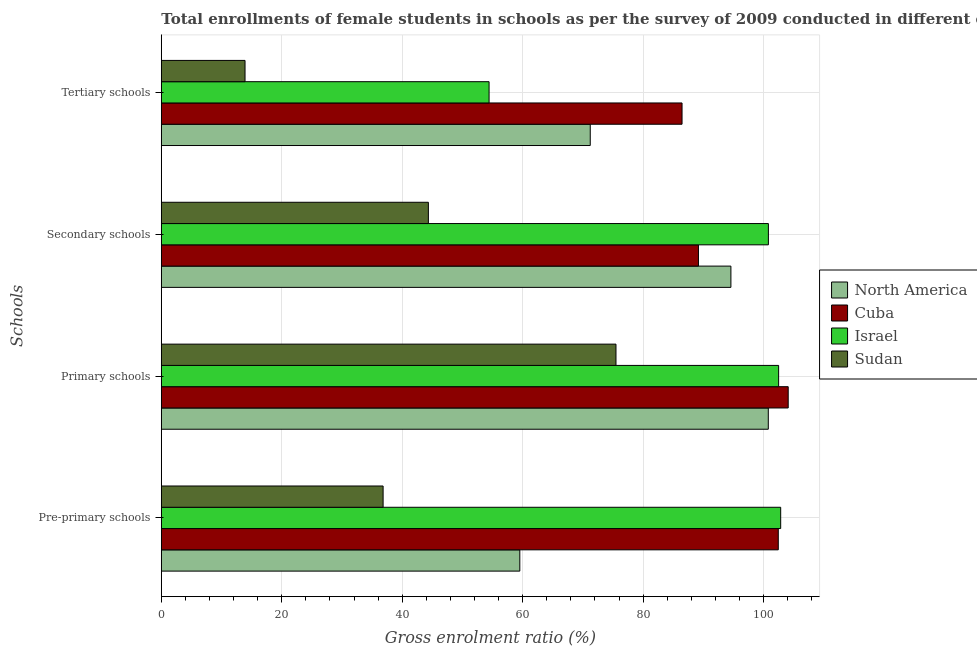How many different coloured bars are there?
Keep it short and to the point. 4. How many groups of bars are there?
Offer a terse response. 4. Are the number of bars per tick equal to the number of legend labels?
Provide a succinct answer. Yes. Are the number of bars on each tick of the Y-axis equal?
Your answer should be compact. Yes. How many bars are there on the 3rd tick from the bottom?
Give a very brief answer. 4. What is the label of the 2nd group of bars from the top?
Offer a very short reply. Secondary schools. What is the gross enrolment ratio(female) in primary schools in Sudan?
Provide a succinct answer. 75.5. Across all countries, what is the maximum gross enrolment ratio(female) in pre-primary schools?
Offer a terse response. 102.85. Across all countries, what is the minimum gross enrolment ratio(female) in pre-primary schools?
Give a very brief answer. 36.83. In which country was the gross enrolment ratio(female) in secondary schools minimum?
Keep it short and to the point. Sudan. What is the total gross enrolment ratio(female) in secondary schools in the graph?
Your response must be concise. 328.92. What is the difference between the gross enrolment ratio(female) in tertiary schools in North America and that in Israel?
Provide a short and direct response. 16.8. What is the difference between the gross enrolment ratio(female) in secondary schools in North America and the gross enrolment ratio(female) in tertiary schools in Israel?
Give a very brief answer. 40.15. What is the average gross enrolment ratio(female) in primary schools per country?
Your answer should be compact. 95.72. What is the difference between the gross enrolment ratio(female) in primary schools and gross enrolment ratio(female) in pre-primary schools in Sudan?
Provide a succinct answer. 38.67. In how many countries, is the gross enrolment ratio(female) in tertiary schools greater than 68 %?
Give a very brief answer. 2. What is the ratio of the gross enrolment ratio(female) in secondary schools in Israel to that in Cuba?
Your response must be concise. 1.13. Is the gross enrolment ratio(female) in pre-primary schools in Israel less than that in Cuba?
Offer a terse response. No. What is the difference between the highest and the second highest gross enrolment ratio(female) in tertiary schools?
Provide a succinct answer. 15.24. What is the difference between the highest and the lowest gross enrolment ratio(female) in primary schools?
Provide a short and direct response. 28.6. Is the sum of the gross enrolment ratio(female) in secondary schools in Israel and Cuba greater than the maximum gross enrolment ratio(female) in tertiary schools across all countries?
Ensure brevity in your answer.  Yes. How many bars are there?
Offer a terse response. 16. How many countries are there in the graph?
Your answer should be very brief. 4. What is the difference between two consecutive major ticks on the X-axis?
Your answer should be very brief. 20. Are the values on the major ticks of X-axis written in scientific E-notation?
Offer a very short reply. No. Does the graph contain grids?
Ensure brevity in your answer.  Yes. How many legend labels are there?
Your response must be concise. 4. How are the legend labels stacked?
Your response must be concise. Vertical. What is the title of the graph?
Provide a succinct answer. Total enrollments of female students in schools as per the survey of 2009 conducted in different countries. Does "Guyana" appear as one of the legend labels in the graph?
Keep it short and to the point. No. What is the label or title of the Y-axis?
Keep it short and to the point. Schools. What is the Gross enrolment ratio (%) of North America in Pre-primary schools?
Provide a succinct answer. 59.53. What is the Gross enrolment ratio (%) in Cuba in Pre-primary schools?
Your answer should be very brief. 102.45. What is the Gross enrolment ratio (%) in Israel in Pre-primary schools?
Your response must be concise. 102.85. What is the Gross enrolment ratio (%) in Sudan in Pre-primary schools?
Your answer should be compact. 36.83. What is the Gross enrolment ratio (%) in North America in Primary schools?
Offer a very short reply. 100.79. What is the Gross enrolment ratio (%) in Cuba in Primary schools?
Your answer should be compact. 104.1. What is the Gross enrolment ratio (%) in Israel in Primary schools?
Your response must be concise. 102.5. What is the Gross enrolment ratio (%) in Sudan in Primary schools?
Make the answer very short. 75.5. What is the Gross enrolment ratio (%) in North America in Secondary schools?
Make the answer very short. 94.58. What is the Gross enrolment ratio (%) in Cuba in Secondary schools?
Your response must be concise. 89.19. What is the Gross enrolment ratio (%) in Israel in Secondary schools?
Give a very brief answer. 100.81. What is the Gross enrolment ratio (%) of Sudan in Secondary schools?
Ensure brevity in your answer.  44.35. What is the Gross enrolment ratio (%) of North America in Tertiary schools?
Give a very brief answer. 71.23. What is the Gross enrolment ratio (%) in Cuba in Tertiary schools?
Offer a terse response. 86.47. What is the Gross enrolment ratio (%) of Israel in Tertiary schools?
Offer a very short reply. 54.43. What is the Gross enrolment ratio (%) in Sudan in Tertiary schools?
Your answer should be compact. 13.9. Across all Schools, what is the maximum Gross enrolment ratio (%) of North America?
Give a very brief answer. 100.79. Across all Schools, what is the maximum Gross enrolment ratio (%) of Cuba?
Offer a terse response. 104.1. Across all Schools, what is the maximum Gross enrolment ratio (%) in Israel?
Give a very brief answer. 102.85. Across all Schools, what is the maximum Gross enrolment ratio (%) of Sudan?
Make the answer very short. 75.5. Across all Schools, what is the minimum Gross enrolment ratio (%) of North America?
Provide a short and direct response. 59.53. Across all Schools, what is the minimum Gross enrolment ratio (%) of Cuba?
Offer a terse response. 86.47. Across all Schools, what is the minimum Gross enrolment ratio (%) in Israel?
Keep it short and to the point. 54.43. Across all Schools, what is the minimum Gross enrolment ratio (%) in Sudan?
Your answer should be compact. 13.9. What is the total Gross enrolment ratio (%) in North America in the graph?
Your response must be concise. 326.12. What is the total Gross enrolment ratio (%) of Cuba in the graph?
Provide a succinct answer. 382.2. What is the total Gross enrolment ratio (%) of Israel in the graph?
Your response must be concise. 360.58. What is the total Gross enrolment ratio (%) of Sudan in the graph?
Your answer should be compact. 170.57. What is the difference between the Gross enrolment ratio (%) in North America in Pre-primary schools and that in Primary schools?
Offer a very short reply. -41.26. What is the difference between the Gross enrolment ratio (%) in Cuba in Pre-primary schools and that in Primary schools?
Provide a succinct answer. -1.65. What is the difference between the Gross enrolment ratio (%) of Israel in Pre-primary schools and that in Primary schools?
Provide a succinct answer. 0.34. What is the difference between the Gross enrolment ratio (%) of Sudan in Pre-primary schools and that in Primary schools?
Ensure brevity in your answer.  -38.67. What is the difference between the Gross enrolment ratio (%) of North America in Pre-primary schools and that in Secondary schools?
Keep it short and to the point. -35.05. What is the difference between the Gross enrolment ratio (%) of Cuba in Pre-primary schools and that in Secondary schools?
Provide a short and direct response. 13.26. What is the difference between the Gross enrolment ratio (%) of Israel in Pre-primary schools and that in Secondary schools?
Provide a succinct answer. 2.04. What is the difference between the Gross enrolment ratio (%) of Sudan in Pre-primary schools and that in Secondary schools?
Ensure brevity in your answer.  -7.52. What is the difference between the Gross enrolment ratio (%) in North America in Pre-primary schools and that in Tertiary schools?
Ensure brevity in your answer.  -11.7. What is the difference between the Gross enrolment ratio (%) in Cuba in Pre-primary schools and that in Tertiary schools?
Provide a succinct answer. 15.98. What is the difference between the Gross enrolment ratio (%) in Israel in Pre-primary schools and that in Tertiary schools?
Your answer should be compact. 48.42. What is the difference between the Gross enrolment ratio (%) of Sudan in Pre-primary schools and that in Tertiary schools?
Make the answer very short. 22.93. What is the difference between the Gross enrolment ratio (%) in North America in Primary schools and that in Secondary schools?
Provide a short and direct response. 6.21. What is the difference between the Gross enrolment ratio (%) in Cuba in Primary schools and that in Secondary schools?
Provide a succinct answer. 14.9. What is the difference between the Gross enrolment ratio (%) in Israel in Primary schools and that in Secondary schools?
Provide a succinct answer. 1.7. What is the difference between the Gross enrolment ratio (%) of Sudan in Primary schools and that in Secondary schools?
Provide a short and direct response. 31.15. What is the difference between the Gross enrolment ratio (%) in North America in Primary schools and that in Tertiary schools?
Ensure brevity in your answer.  29.56. What is the difference between the Gross enrolment ratio (%) of Cuba in Primary schools and that in Tertiary schools?
Ensure brevity in your answer.  17.63. What is the difference between the Gross enrolment ratio (%) of Israel in Primary schools and that in Tertiary schools?
Ensure brevity in your answer.  48.08. What is the difference between the Gross enrolment ratio (%) of Sudan in Primary schools and that in Tertiary schools?
Ensure brevity in your answer.  61.6. What is the difference between the Gross enrolment ratio (%) in North America in Secondary schools and that in Tertiary schools?
Provide a short and direct response. 23.35. What is the difference between the Gross enrolment ratio (%) of Cuba in Secondary schools and that in Tertiary schools?
Offer a terse response. 2.73. What is the difference between the Gross enrolment ratio (%) of Israel in Secondary schools and that in Tertiary schools?
Your answer should be very brief. 46.38. What is the difference between the Gross enrolment ratio (%) in Sudan in Secondary schools and that in Tertiary schools?
Keep it short and to the point. 30.44. What is the difference between the Gross enrolment ratio (%) in North America in Pre-primary schools and the Gross enrolment ratio (%) in Cuba in Primary schools?
Your response must be concise. -44.57. What is the difference between the Gross enrolment ratio (%) of North America in Pre-primary schools and the Gross enrolment ratio (%) of Israel in Primary schools?
Give a very brief answer. -42.98. What is the difference between the Gross enrolment ratio (%) in North America in Pre-primary schools and the Gross enrolment ratio (%) in Sudan in Primary schools?
Offer a very short reply. -15.97. What is the difference between the Gross enrolment ratio (%) of Cuba in Pre-primary schools and the Gross enrolment ratio (%) of Israel in Primary schools?
Make the answer very short. -0.06. What is the difference between the Gross enrolment ratio (%) of Cuba in Pre-primary schools and the Gross enrolment ratio (%) of Sudan in Primary schools?
Offer a terse response. 26.95. What is the difference between the Gross enrolment ratio (%) in Israel in Pre-primary schools and the Gross enrolment ratio (%) in Sudan in Primary schools?
Give a very brief answer. 27.35. What is the difference between the Gross enrolment ratio (%) in North America in Pre-primary schools and the Gross enrolment ratio (%) in Cuba in Secondary schools?
Your answer should be compact. -29.66. What is the difference between the Gross enrolment ratio (%) of North America in Pre-primary schools and the Gross enrolment ratio (%) of Israel in Secondary schools?
Provide a succinct answer. -41.28. What is the difference between the Gross enrolment ratio (%) in North America in Pre-primary schools and the Gross enrolment ratio (%) in Sudan in Secondary schools?
Provide a short and direct response. 15.18. What is the difference between the Gross enrolment ratio (%) in Cuba in Pre-primary schools and the Gross enrolment ratio (%) in Israel in Secondary schools?
Offer a terse response. 1.64. What is the difference between the Gross enrolment ratio (%) of Cuba in Pre-primary schools and the Gross enrolment ratio (%) of Sudan in Secondary schools?
Offer a terse response. 58.1. What is the difference between the Gross enrolment ratio (%) of Israel in Pre-primary schools and the Gross enrolment ratio (%) of Sudan in Secondary schools?
Offer a very short reply. 58.5. What is the difference between the Gross enrolment ratio (%) of North America in Pre-primary schools and the Gross enrolment ratio (%) of Cuba in Tertiary schools?
Your answer should be very brief. -26.94. What is the difference between the Gross enrolment ratio (%) of North America in Pre-primary schools and the Gross enrolment ratio (%) of Israel in Tertiary schools?
Keep it short and to the point. 5.1. What is the difference between the Gross enrolment ratio (%) of North America in Pre-primary schools and the Gross enrolment ratio (%) of Sudan in Tertiary schools?
Your response must be concise. 45.63. What is the difference between the Gross enrolment ratio (%) of Cuba in Pre-primary schools and the Gross enrolment ratio (%) of Israel in Tertiary schools?
Keep it short and to the point. 48.02. What is the difference between the Gross enrolment ratio (%) in Cuba in Pre-primary schools and the Gross enrolment ratio (%) in Sudan in Tertiary schools?
Offer a very short reply. 88.55. What is the difference between the Gross enrolment ratio (%) of Israel in Pre-primary schools and the Gross enrolment ratio (%) of Sudan in Tertiary schools?
Make the answer very short. 88.94. What is the difference between the Gross enrolment ratio (%) in North America in Primary schools and the Gross enrolment ratio (%) in Cuba in Secondary schools?
Provide a short and direct response. 11.6. What is the difference between the Gross enrolment ratio (%) in North America in Primary schools and the Gross enrolment ratio (%) in Israel in Secondary schools?
Give a very brief answer. -0.02. What is the difference between the Gross enrolment ratio (%) of North America in Primary schools and the Gross enrolment ratio (%) of Sudan in Secondary schools?
Offer a terse response. 56.44. What is the difference between the Gross enrolment ratio (%) of Cuba in Primary schools and the Gross enrolment ratio (%) of Israel in Secondary schools?
Ensure brevity in your answer.  3.29. What is the difference between the Gross enrolment ratio (%) of Cuba in Primary schools and the Gross enrolment ratio (%) of Sudan in Secondary schools?
Your answer should be compact. 59.75. What is the difference between the Gross enrolment ratio (%) in Israel in Primary schools and the Gross enrolment ratio (%) in Sudan in Secondary schools?
Your answer should be very brief. 58.16. What is the difference between the Gross enrolment ratio (%) in North America in Primary schools and the Gross enrolment ratio (%) in Cuba in Tertiary schools?
Ensure brevity in your answer.  14.32. What is the difference between the Gross enrolment ratio (%) in North America in Primary schools and the Gross enrolment ratio (%) in Israel in Tertiary schools?
Keep it short and to the point. 46.36. What is the difference between the Gross enrolment ratio (%) of North America in Primary schools and the Gross enrolment ratio (%) of Sudan in Tertiary schools?
Ensure brevity in your answer.  86.89. What is the difference between the Gross enrolment ratio (%) of Cuba in Primary schools and the Gross enrolment ratio (%) of Israel in Tertiary schools?
Ensure brevity in your answer.  49.67. What is the difference between the Gross enrolment ratio (%) of Cuba in Primary schools and the Gross enrolment ratio (%) of Sudan in Tertiary schools?
Give a very brief answer. 90.19. What is the difference between the Gross enrolment ratio (%) of Israel in Primary schools and the Gross enrolment ratio (%) of Sudan in Tertiary schools?
Your answer should be compact. 88.6. What is the difference between the Gross enrolment ratio (%) in North America in Secondary schools and the Gross enrolment ratio (%) in Cuba in Tertiary schools?
Your answer should be very brief. 8.11. What is the difference between the Gross enrolment ratio (%) of North America in Secondary schools and the Gross enrolment ratio (%) of Israel in Tertiary schools?
Offer a very short reply. 40.15. What is the difference between the Gross enrolment ratio (%) in North America in Secondary schools and the Gross enrolment ratio (%) in Sudan in Tertiary schools?
Give a very brief answer. 80.68. What is the difference between the Gross enrolment ratio (%) of Cuba in Secondary schools and the Gross enrolment ratio (%) of Israel in Tertiary schools?
Provide a succinct answer. 34.77. What is the difference between the Gross enrolment ratio (%) of Cuba in Secondary schools and the Gross enrolment ratio (%) of Sudan in Tertiary schools?
Your answer should be very brief. 75.29. What is the difference between the Gross enrolment ratio (%) of Israel in Secondary schools and the Gross enrolment ratio (%) of Sudan in Tertiary schools?
Offer a very short reply. 86.9. What is the average Gross enrolment ratio (%) of North America per Schools?
Your response must be concise. 81.53. What is the average Gross enrolment ratio (%) of Cuba per Schools?
Keep it short and to the point. 95.55. What is the average Gross enrolment ratio (%) of Israel per Schools?
Ensure brevity in your answer.  90.15. What is the average Gross enrolment ratio (%) in Sudan per Schools?
Give a very brief answer. 42.64. What is the difference between the Gross enrolment ratio (%) of North America and Gross enrolment ratio (%) of Cuba in Pre-primary schools?
Make the answer very short. -42.92. What is the difference between the Gross enrolment ratio (%) of North America and Gross enrolment ratio (%) of Israel in Pre-primary schools?
Give a very brief answer. -43.32. What is the difference between the Gross enrolment ratio (%) of North America and Gross enrolment ratio (%) of Sudan in Pre-primary schools?
Give a very brief answer. 22.7. What is the difference between the Gross enrolment ratio (%) of Cuba and Gross enrolment ratio (%) of Israel in Pre-primary schools?
Give a very brief answer. -0.4. What is the difference between the Gross enrolment ratio (%) in Cuba and Gross enrolment ratio (%) in Sudan in Pre-primary schools?
Keep it short and to the point. 65.62. What is the difference between the Gross enrolment ratio (%) of Israel and Gross enrolment ratio (%) of Sudan in Pre-primary schools?
Your answer should be very brief. 66.02. What is the difference between the Gross enrolment ratio (%) in North America and Gross enrolment ratio (%) in Cuba in Primary schools?
Give a very brief answer. -3.31. What is the difference between the Gross enrolment ratio (%) in North America and Gross enrolment ratio (%) in Israel in Primary schools?
Make the answer very short. -1.72. What is the difference between the Gross enrolment ratio (%) in North America and Gross enrolment ratio (%) in Sudan in Primary schools?
Your answer should be very brief. 25.29. What is the difference between the Gross enrolment ratio (%) of Cuba and Gross enrolment ratio (%) of Israel in Primary schools?
Keep it short and to the point. 1.59. What is the difference between the Gross enrolment ratio (%) of Cuba and Gross enrolment ratio (%) of Sudan in Primary schools?
Your answer should be very brief. 28.6. What is the difference between the Gross enrolment ratio (%) of Israel and Gross enrolment ratio (%) of Sudan in Primary schools?
Offer a very short reply. 27.01. What is the difference between the Gross enrolment ratio (%) of North America and Gross enrolment ratio (%) of Cuba in Secondary schools?
Provide a succinct answer. 5.39. What is the difference between the Gross enrolment ratio (%) of North America and Gross enrolment ratio (%) of Israel in Secondary schools?
Provide a short and direct response. -6.23. What is the difference between the Gross enrolment ratio (%) in North America and Gross enrolment ratio (%) in Sudan in Secondary schools?
Ensure brevity in your answer.  50.23. What is the difference between the Gross enrolment ratio (%) in Cuba and Gross enrolment ratio (%) in Israel in Secondary schools?
Your answer should be compact. -11.61. What is the difference between the Gross enrolment ratio (%) in Cuba and Gross enrolment ratio (%) in Sudan in Secondary schools?
Provide a short and direct response. 44.85. What is the difference between the Gross enrolment ratio (%) in Israel and Gross enrolment ratio (%) in Sudan in Secondary schools?
Your response must be concise. 56.46. What is the difference between the Gross enrolment ratio (%) in North America and Gross enrolment ratio (%) in Cuba in Tertiary schools?
Your answer should be very brief. -15.24. What is the difference between the Gross enrolment ratio (%) of North America and Gross enrolment ratio (%) of Sudan in Tertiary schools?
Make the answer very short. 57.32. What is the difference between the Gross enrolment ratio (%) of Cuba and Gross enrolment ratio (%) of Israel in Tertiary schools?
Offer a very short reply. 32.04. What is the difference between the Gross enrolment ratio (%) in Cuba and Gross enrolment ratio (%) in Sudan in Tertiary schools?
Offer a very short reply. 72.56. What is the difference between the Gross enrolment ratio (%) of Israel and Gross enrolment ratio (%) of Sudan in Tertiary schools?
Offer a terse response. 40.52. What is the ratio of the Gross enrolment ratio (%) in North America in Pre-primary schools to that in Primary schools?
Ensure brevity in your answer.  0.59. What is the ratio of the Gross enrolment ratio (%) of Cuba in Pre-primary schools to that in Primary schools?
Offer a terse response. 0.98. What is the ratio of the Gross enrolment ratio (%) of Israel in Pre-primary schools to that in Primary schools?
Offer a terse response. 1. What is the ratio of the Gross enrolment ratio (%) of Sudan in Pre-primary schools to that in Primary schools?
Provide a succinct answer. 0.49. What is the ratio of the Gross enrolment ratio (%) in North America in Pre-primary schools to that in Secondary schools?
Keep it short and to the point. 0.63. What is the ratio of the Gross enrolment ratio (%) in Cuba in Pre-primary schools to that in Secondary schools?
Offer a terse response. 1.15. What is the ratio of the Gross enrolment ratio (%) in Israel in Pre-primary schools to that in Secondary schools?
Your response must be concise. 1.02. What is the ratio of the Gross enrolment ratio (%) of Sudan in Pre-primary schools to that in Secondary schools?
Offer a terse response. 0.83. What is the ratio of the Gross enrolment ratio (%) of North America in Pre-primary schools to that in Tertiary schools?
Keep it short and to the point. 0.84. What is the ratio of the Gross enrolment ratio (%) of Cuba in Pre-primary schools to that in Tertiary schools?
Your response must be concise. 1.18. What is the ratio of the Gross enrolment ratio (%) in Israel in Pre-primary schools to that in Tertiary schools?
Provide a succinct answer. 1.89. What is the ratio of the Gross enrolment ratio (%) of Sudan in Pre-primary schools to that in Tertiary schools?
Give a very brief answer. 2.65. What is the ratio of the Gross enrolment ratio (%) in North America in Primary schools to that in Secondary schools?
Keep it short and to the point. 1.07. What is the ratio of the Gross enrolment ratio (%) in Cuba in Primary schools to that in Secondary schools?
Give a very brief answer. 1.17. What is the ratio of the Gross enrolment ratio (%) of Israel in Primary schools to that in Secondary schools?
Provide a short and direct response. 1.02. What is the ratio of the Gross enrolment ratio (%) in Sudan in Primary schools to that in Secondary schools?
Give a very brief answer. 1.7. What is the ratio of the Gross enrolment ratio (%) in North America in Primary schools to that in Tertiary schools?
Your response must be concise. 1.42. What is the ratio of the Gross enrolment ratio (%) of Cuba in Primary schools to that in Tertiary schools?
Offer a very short reply. 1.2. What is the ratio of the Gross enrolment ratio (%) in Israel in Primary schools to that in Tertiary schools?
Provide a succinct answer. 1.88. What is the ratio of the Gross enrolment ratio (%) in Sudan in Primary schools to that in Tertiary schools?
Your answer should be very brief. 5.43. What is the ratio of the Gross enrolment ratio (%) in North America in Secondary schools to that in Tertiary schools?
Keep it short and to the point. 1.33. What is the ratio of the Gross enrolment ratio (%) in Cuba in Secondary schools to that in Tertiary schools?
Give a very brief answer. 1.03. What is the ratio of the Gross enrolment ratio (%) in Israel in Secondary schools to that in Tertiary schools?
Provide a short and direct response. 1.85. What is the ratio of the Gross enrolment ratio (%) in Sudan in Secondary schools to that in Tertiary schools?
Ensure brevity in your answer.  3.19. What is the difference between the highest and the second highest Gross enrolment ratio (%) of North America?
Ensure brevity in your answer.  6.21. What is the difference between the highest and the second highest Gross enrolment ratio (%) in Cuba?
Keep it short and to the point. 1.65. What is the difference between the highest and the second highest Gross enrolment ratio (%) of Israel?
Offer a very short reply. 0.34. What is the difference between the highest and the second highest Gross enrolment ratio (%) in Sudan?
Make the answer very short. 31.15. What is the difference between the highest and the lowest Gross enrolment ratio (%) in North America?
Keep it short and to the point. 41.26. What is the difference between the highest and the lowest Gross enrolment ratio (%) of Cuba?
Offer a very short reply. 17.63. What is the difference between the highest and the lowest Gross enrolment ratio (%) of Israel?
Offer a terse response. 48.42. What is the difference between the highest and the lowest Gross enrolment ratio (%) in Sudan?
Offer a very short reply. 61.6. 